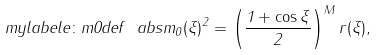<formula> <loc_0><loc_0><loc_500><loc_500>\ m y l a b e l { e \colon m 0 d e f } \ a b s { m _ { 0 } ( \xi ) } ^ { 2 } = \left ( \frac { 1 + \cos \xi } { 2 } \right ) ^ { M } r ( \xi ) ,</formula> 